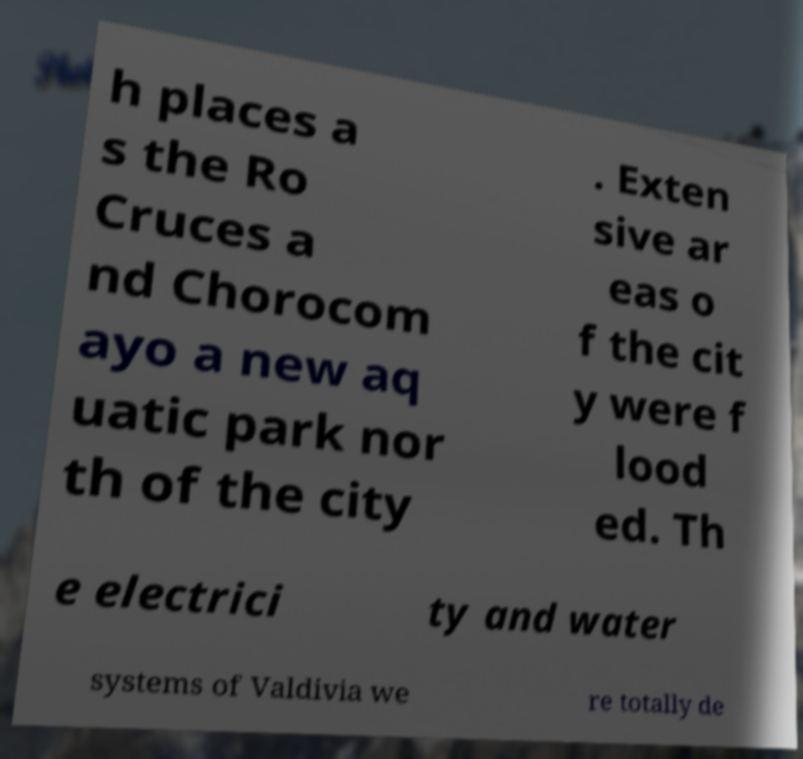Could you extract and type out the text from this image? h places a s the Ro Cruces a nd Chorocom ayo a new aq uatic park nor th of the city . Exten sive ar eas o f the cit y were f lood ed. Th e electrici ty and water systems of Valdivia we re totally de 